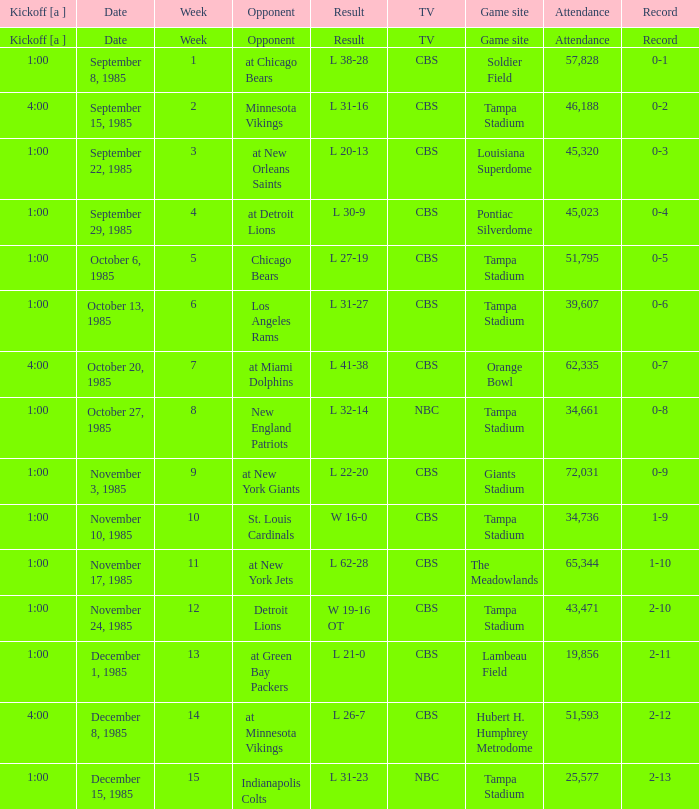Give me the kickoff time of the game that was aired on CBS against the St. Louis Cardinals.  1:00. 